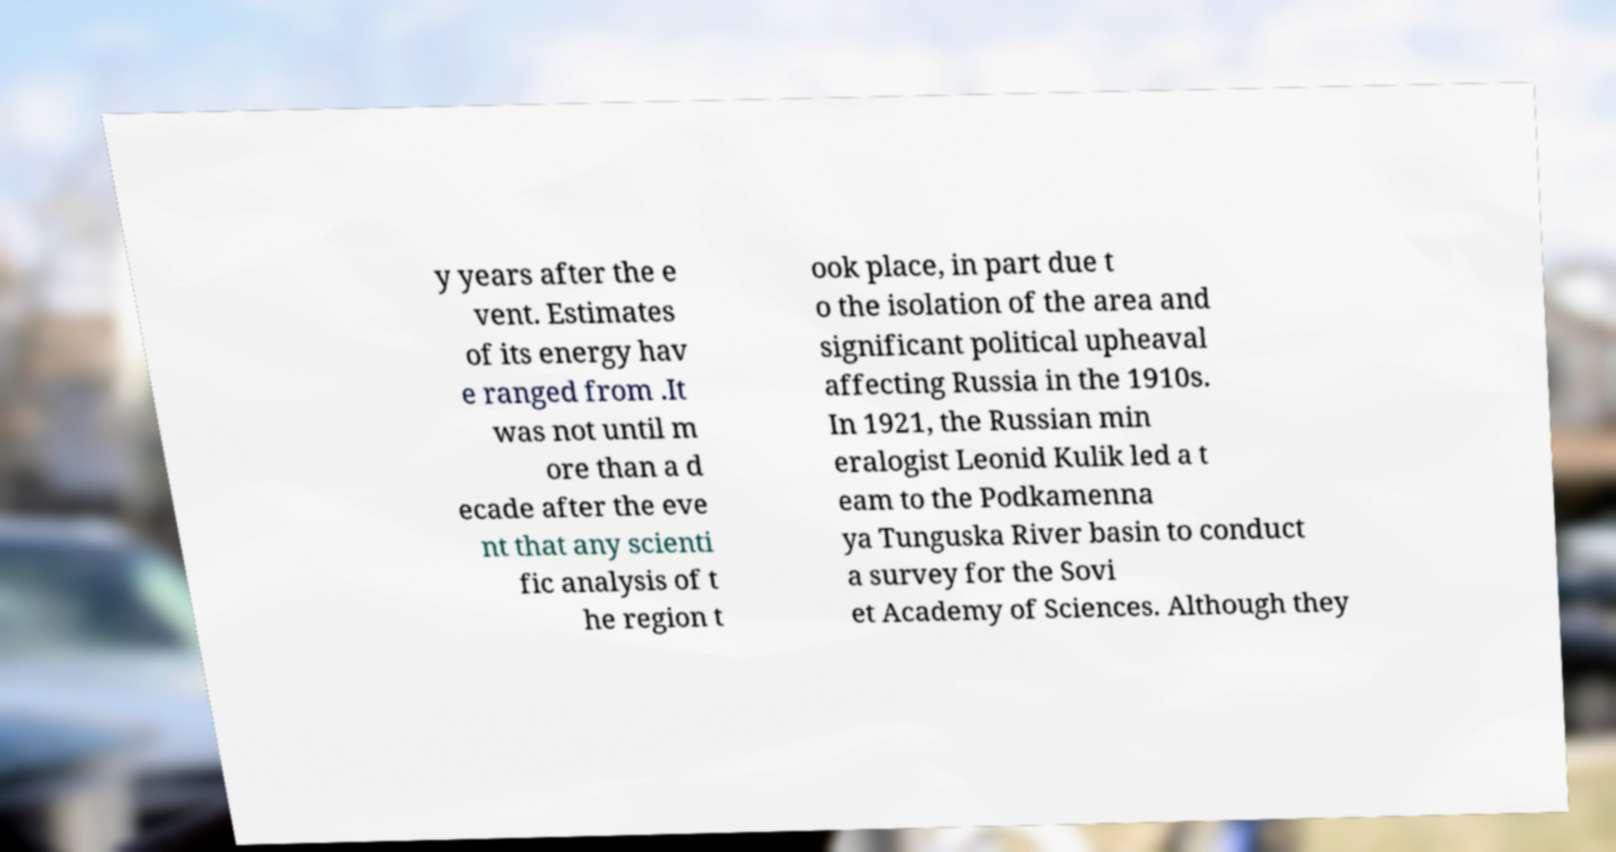For documentation purposes, I need the text within this image transcribed. Could you provide that? y years after the e vent. Estimates of its energy hav e ranged from .It was not until m ore than a d ecade after the eve nt that any scienti fic analysis of t he region t ook place, in part due t o the isolation of the area and significant political upheaval affecting Russia in the 1910s. In 1921, the Russian min eralogist Leonid Kulik led a t eam to the Podkamenna ya Tunguska River basin to conduct a survey for the Sovi et Academy of Sciences. Although they 